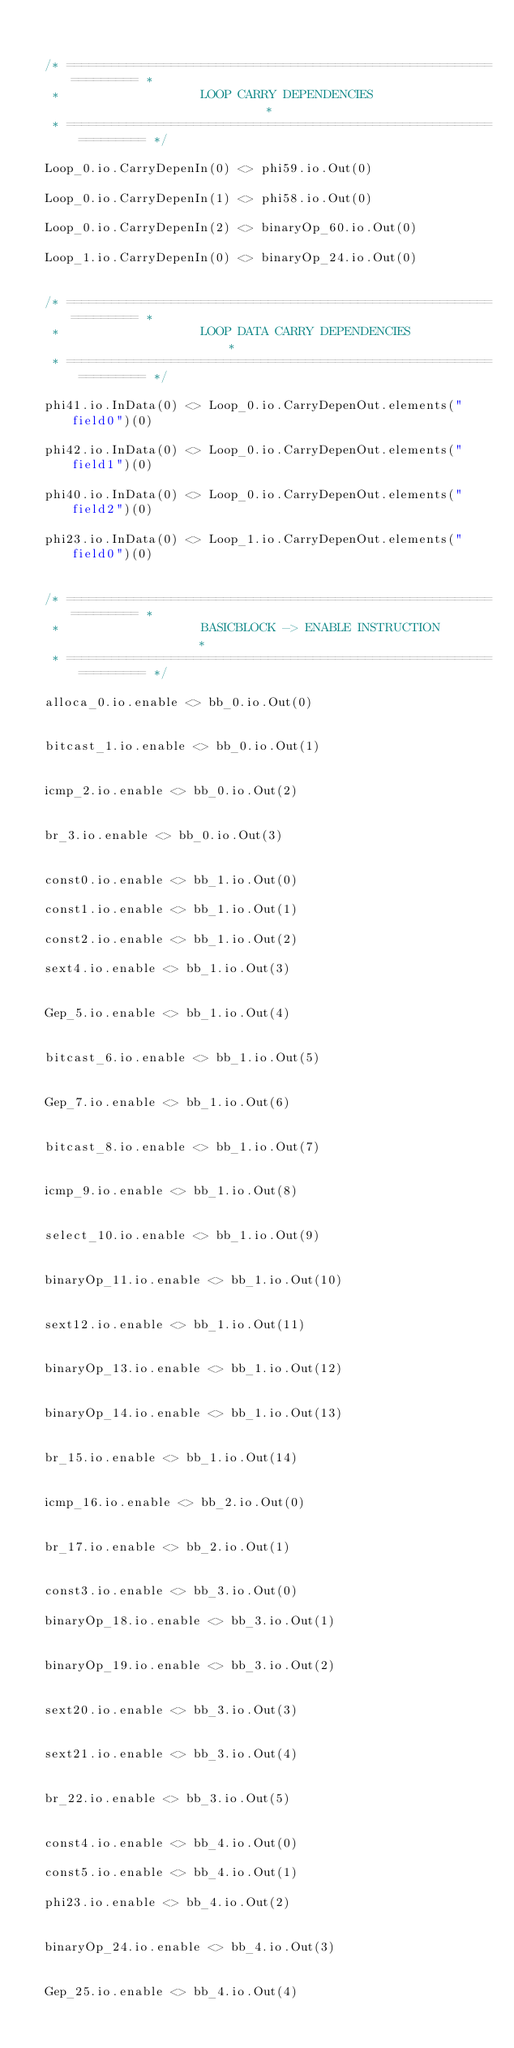Convert code to text. <code><loc_0><loc_0><loc_500><loc_500><_Scala_>

  /* ================================================================== *
   *                   LOOP CARRY DEPENDENCIES                          *
   * ================================================================== */

  Loop_0.io.CarryDepenIn(0) <> phi59.io.Out(0)

  Loop_0.io.CarryDepenIn(1) <> phi58.io.Out(0)

  Loop_0.io.CarryDepenIn(2) <> binaryOp_60.io.Out(0)

  Loop_1.io.CarryDepenIn(0) <> binaryOp_24.io.Out(0)


  /* ================================================================== *
   *                   LOOP DATA CARRY DEPENDENCIES                     *
   * ================================================================== */

  phi41.io.InData(0) <> Loop_0.io.CarryDepenOut.elements("field0")(0)

  phi42.io.InData(0) <> Loop_0.io.CarryDepenOut.elements("field1")(0)

  phi40.io.InData(0) <> Loop_0.io.CarryDepenOut.elements("field2")(0)

  phi23.io.InData(0) <> Loop_1.io.CarryDepenOut.elements("field0")(0)


  /* ================================================================== *
   *                   BASICBLOCK -> ENABLE INSTRUCTION                 *
   * ================================================================== */

  alloca_0.io.enable <> bb_0.io.Out(0)


  bitcast_1.io.enable <> bb_0.io.Out(1)


  icmp_2.io.enable <> bb_0.io.Out(2)


  br_3.io.enable <> bb_0.io.Out(3)


  const0.io.enable <> bb_1.io.Out(0)

  const1.io.enable <> bb_1.io.Out(1)

  const2.io.enable <> bb_1.io.Out(2)

  sext4.io.enable <> bb_1.io.Out(3)


  Gep_5.io.enable <> bb_1.io.Out(4)


  bitcast_6.io.enable <> bb_1.io.Out(5)


  Gep_7.io.enable <> bb_1.io.Out(6)


  bitcast_8.io.enable <> bb_1.io.Out(7)


  icmp_9.io.enable <> bb_1.io.Out(8)


  select_10.io.enable <> bb_1.io.Out(9)


  binaryOp_11.io.enable <> bb_1.io.Out(10)


  sext12.io.enable <> bb_1.io.Out(11)


  binaryOp_13.io.enable <> bb_1.io.Out(12)


  binaryOp_14.io.enable <> bb_1.io.Out(13)


  br_15.io.enable <> bb_1.io.Out(14)


  icmp_16.io.enable <> bb_2.io.Out(0)


  br_17.io.enable <> bb_2.io.Out(1)


  const3.io.enable <> bb_3.io.Out(0)

  binaryOp_18.io.enable <> bb_3.io.Out(1)


  binaryOp_19.io.enable <> bb_3.io.Out(2)


  sext20.io.enable <> bb_3.io.Out(3)


  sext21.io.enable <> bb_3.io.Out(4)


  br_22.io.enable <> bb_3.io.Out(5)


  const4.io.enable <> bb_4.io.Out(0)

  const5.io.enable <> bb_4.io.Out(1)

  phi23.io.enable <> bb_4.io.Out(2)


  binaryOp_24.io.enable <> bb_4.io.Out(3)


  Gep_25.io.enable <> bb_4.io.Out(4)

</code> 